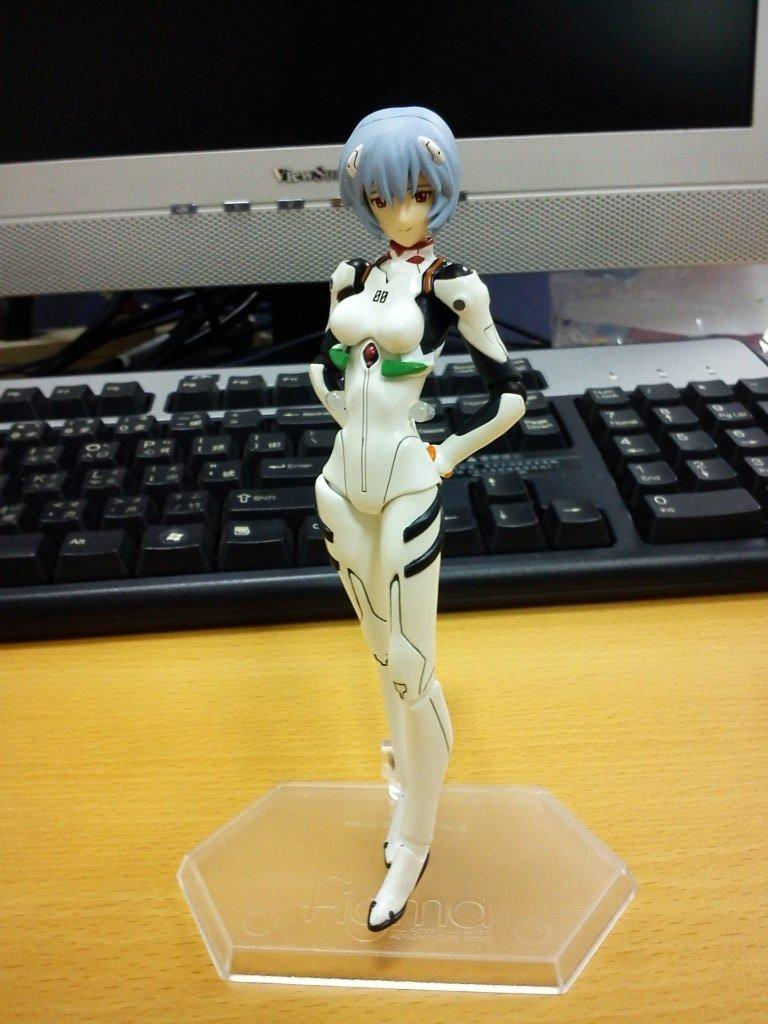What is on the wooden table in the image? There is a toy on the wooden table. What else can be seen on the table? There are objects on the table, including a computer, wires, and a keyboard. What is the purpose of the wires associated with the computer? The wires are likely used to connect the computer to other devices or to provide power. What type of device is present on the table? There is a computer on the table. What scientific experiment is being conducted in the image? There is no scientific experiment visible in the image; it primarily features a toy and a computer setup. 